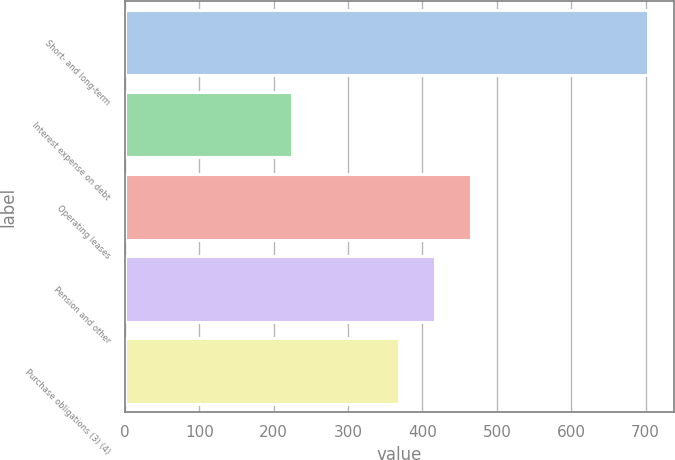Convert chart to OTSL. <chart><loc_0><loc_0><loc_500><loc_500><bar_chart><fcel>Short- and long-term<fcel>Interest expense on debt<fcel>Operating leases<fcel>Pension and other<fcel>Purchase obligations (3) (4)<nl><fcel>703<fcel>224<fcel>464.8<fcel>416.9<fcel>369<nl></chart> 